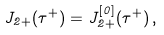Convert formula to latex. <formula><loc_0><loc_0><loc_500><loc_500>J _ { 2 + } ( \tau ^ { + } ) = J _ { 2 + } ^ { [ 0 ] } ( \tau ^ { + } ) \, ,</formula> 